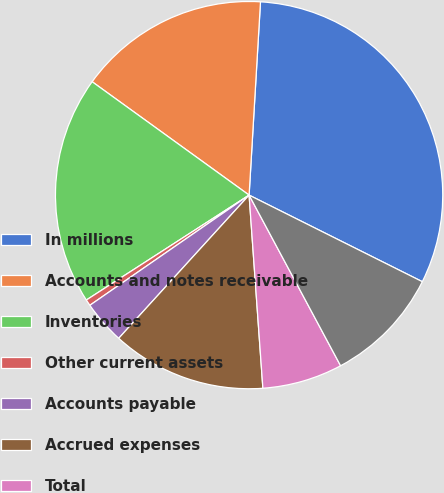Convert chart. <chart><loc_0><loc_0><loc_500><loc_500><pie_chart><fcel>In millions<fcel>Accounts and notes receivable<fcel>Inventories<fcel>Other current assets<fcel>Accounts payable<fcel>Accrued expenses<fcel>Total<fcel>Cash payments for income taxes<nl><fcel>31.44%<fcel>15.98%<fcel>19.07%<fcel>0.52%<fcel>3.61%<fcel>12.89%<fcel>6.7%<fcel>9.79%<nl></chart> 